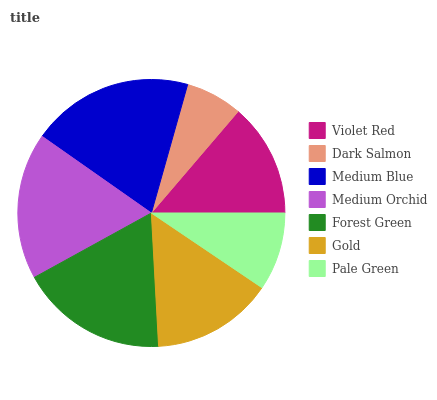Is Dark Salmon the minimum?
Answer yes or no. Yes. Is Medium Blue the maximum?
Answer yes or no. Yes. Is Medium Blue the minimum?
Answer yes or no. No. Is Dark Salmon the maximum?
Answer yes or no. No. Is Medium Blue greater than Dark Salmon?
Answer yes or no. Yes. Is Dark Salmon less than Medium Blue?
Answer yes or no. Yes. Is Dark Salmon greater than Medium Blue?
Answer yes or no. No. Is Medium Blue less than Dark Salmon?
Answer yes or no. No. Is Gold the high median?
Answer yes or no. Yes. Is Gold the low median?
Answer yes or no. Yes. Is Medium Blue the high median?
Answer yes or no. No. Is Violet Red the low median?
Answer yes or no. No. 